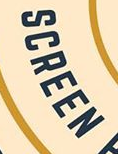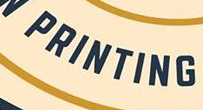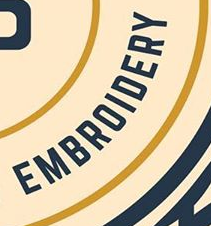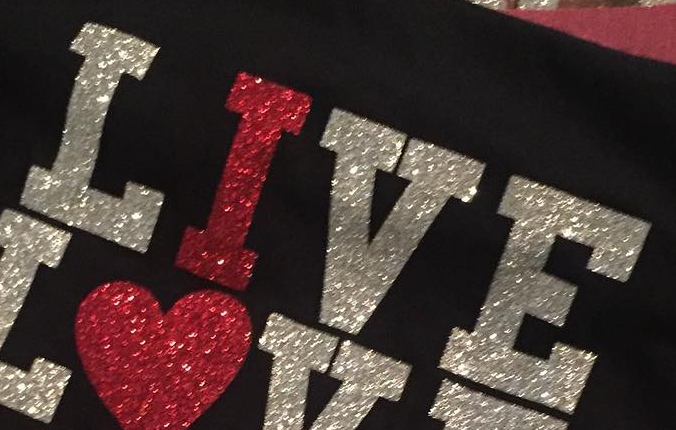Read the text content from these images in order, separated by a semicolon. SCREEN; PRINTING; EMBROIDERY; LIVE 